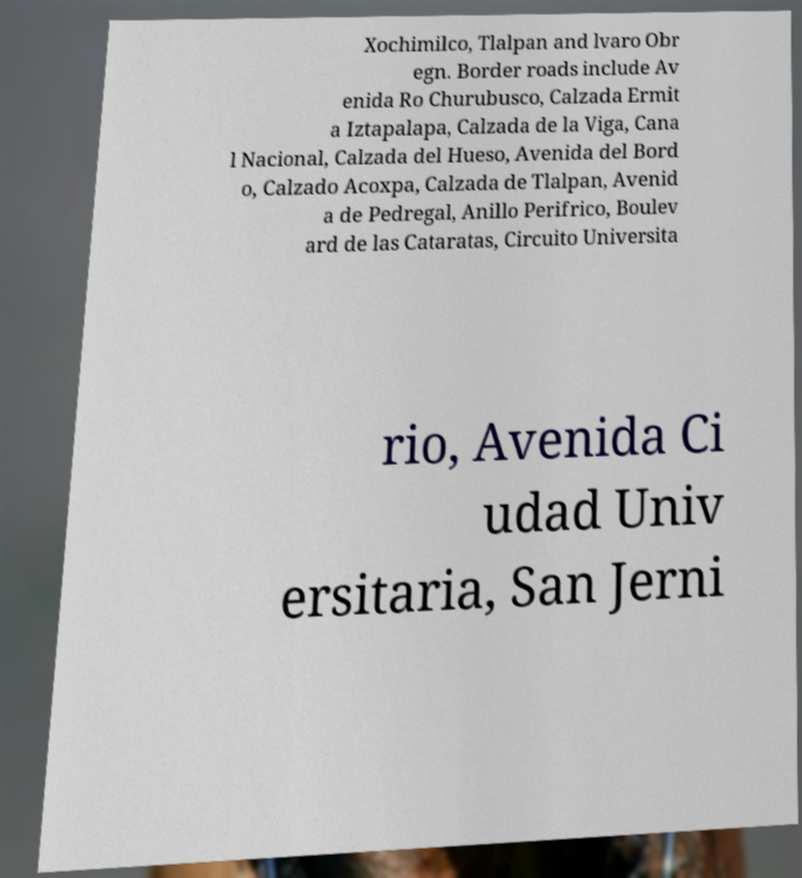What messages or text are displayed in this image? I need them in a readable, typed format. Xochimilco, Tlalpan and lvaro Obr egn. Border roads include Av enida Ro Churubusco, Calzada Ermit a Iztapalapa, Calzada de la Viga, Cana l Nacional, Calzada del Hueso, Avenida del Bord o, Calzado Acoxpa, Calzada de Tlalpan, Avenid a de Pedregal, Anillo Perifrico, Boulev ard de las Cataratas, Circuito Universita rio, Avenida Ci udad Univ ersitaria, San Jerni 